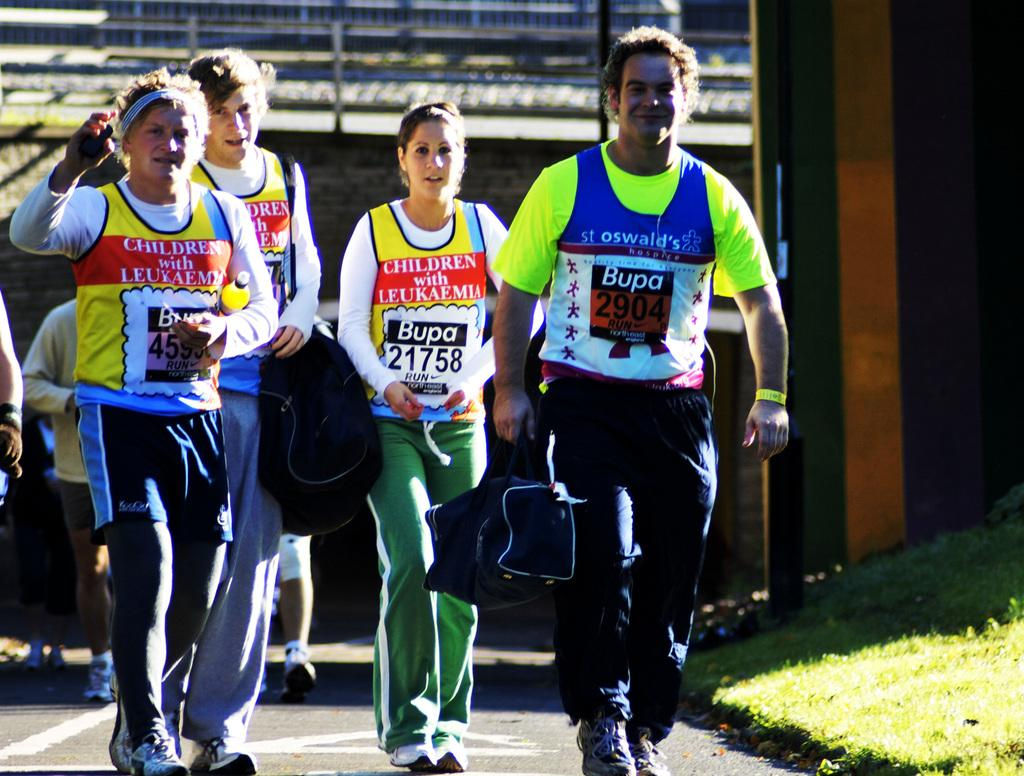<image>
Create a compact narrative representing the image presented. A group of people wearing jerseys participating in an event for Children with Leukemia 